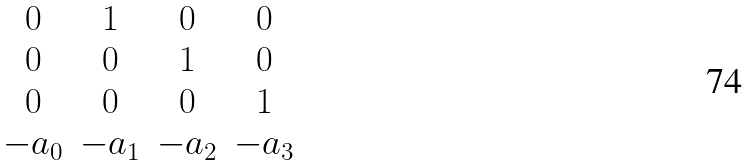Convert formula to latex. <formula><loc_0><loc_0><loc_500><loc_500>\begin{matrix} 0 & 1 & 0 & 0 \\ 0 & 0 & 1 & 0 \\ 0 & 0 & 0 & 1 \\ - a _ { 0 } & - a _ { 1 } & - a _ { 2 } & - a _ { 3 } \end{matrix}</formula> 